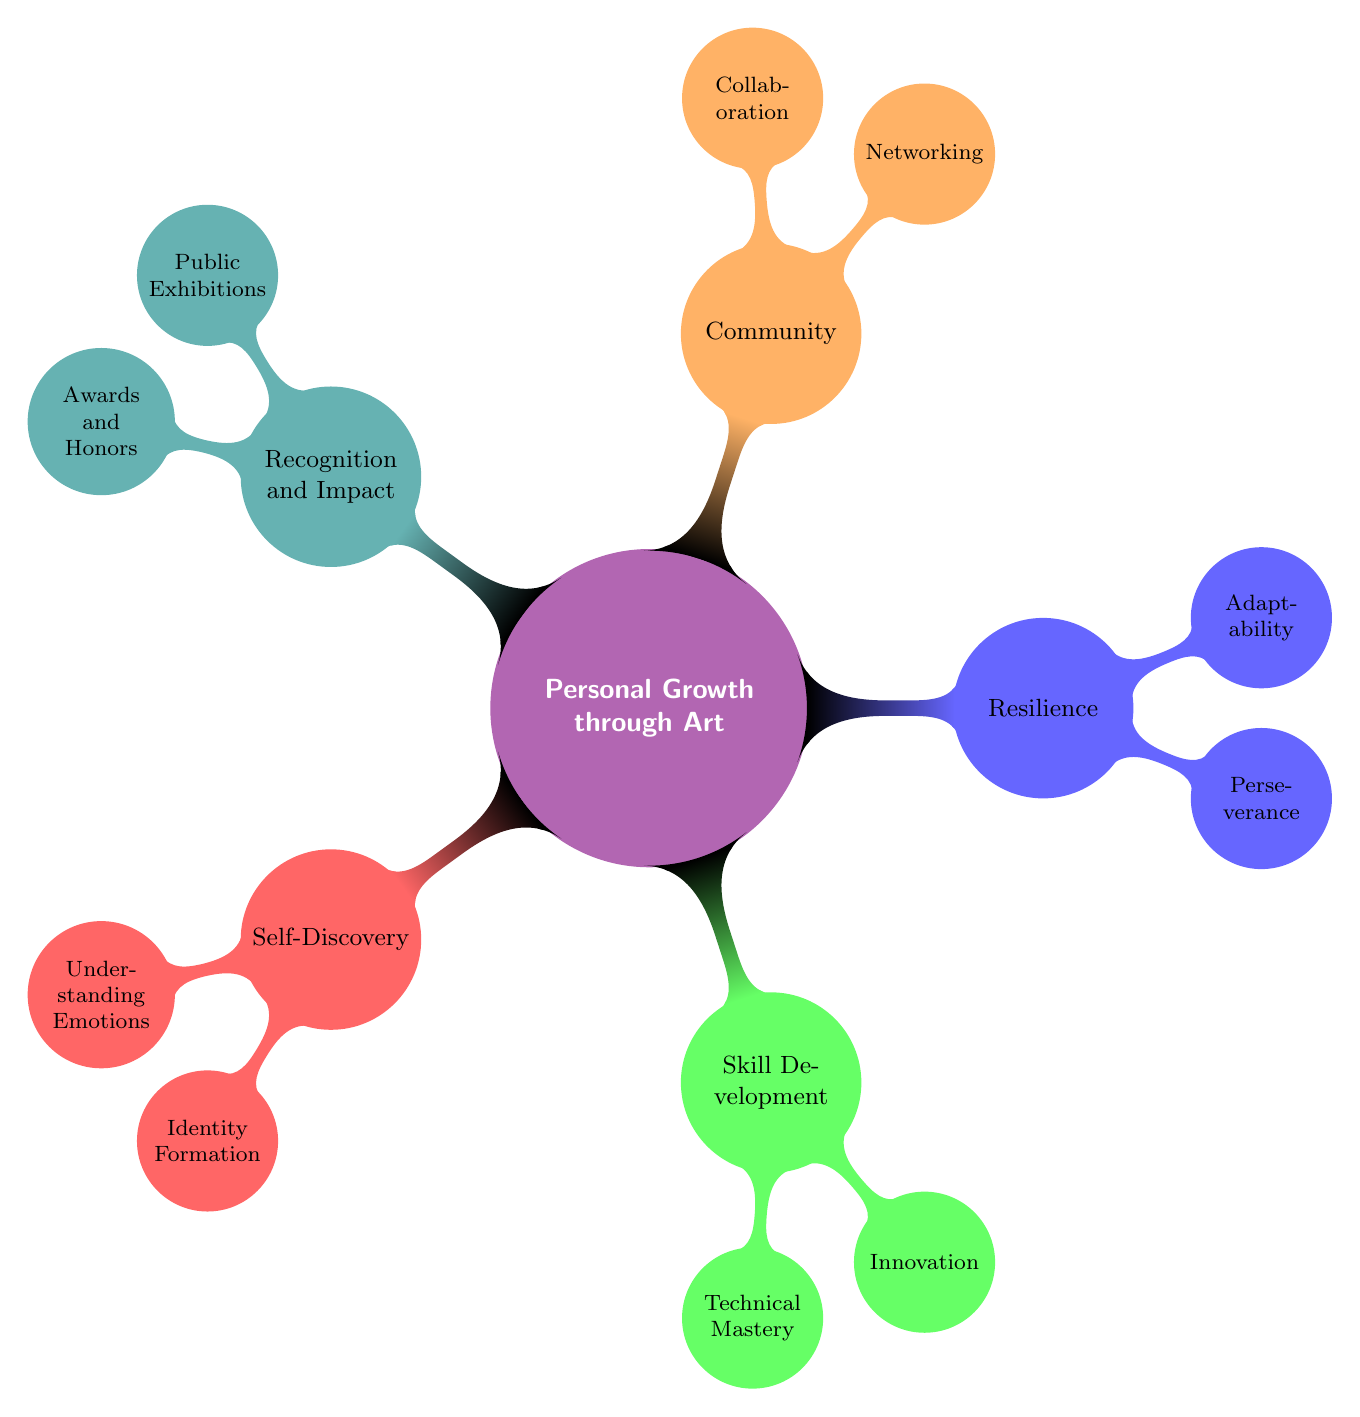What are the two primary categories under "Personal Growth through Art"? The diagram shows that "Personal Growth through Art" has five primary categories: "Self-Discovery," "Skill Development," "Resilience," "Community," and "Recognition and Impact."
Answer: Self-Discovery, Skill Development How many nodes are there under "Resilience"? The "Resilience" node has two sub-nodes: "Perseverance" and "Adaptability," which means it has a total of two nodes under it.
Answer: 2 What does "Networking" refer to in the context of the diagram? The "Networking" node under "Community" signifies the action of building connections with other artists and professionals, highlighting the importance of relationships in personal growth through art.
Answer: Building connections Which category includes "Technical Mastery"? The "Technical Mastery" node is found under the "Skill Development" category, indicating its relevance to improving artistic techniques.
Answer: Skill Development What is the relationship between "Innovation" and "Skill Development"? "Innovation" is one of the two sub-nodes stemming directly from "Skill Development," showcasing that it is a component or aspect of skill enhancement in art practices.
Answer: Sub-node relationship What is a key lesson learned from the "Resilience" category? The "Resilience" category encompasses important lessons such as "Perseverance" and "Adaptability," illustrating the significance of overcoming challenges and learning from mistakes.
Answer: Overcoming challenges How are "Public Exhibitions" significant in the context of recognition? The "Public Exhibitions" node under "Recognition and Impact" highlights the importance of showcasing work in galleries and public spaces as a way to garner recognition for artistic contributions.
Answer: Showcasing work What do both "Perseverance" and "Adaptability" signify collectively? Together, "Perseverance" and "Adaptability" reflect the overarching theme of resilience in art, emphasizing overcoming creative blocks and adjusting to new challenges as key aspects of personal growth.
Answer: Resilience theme 